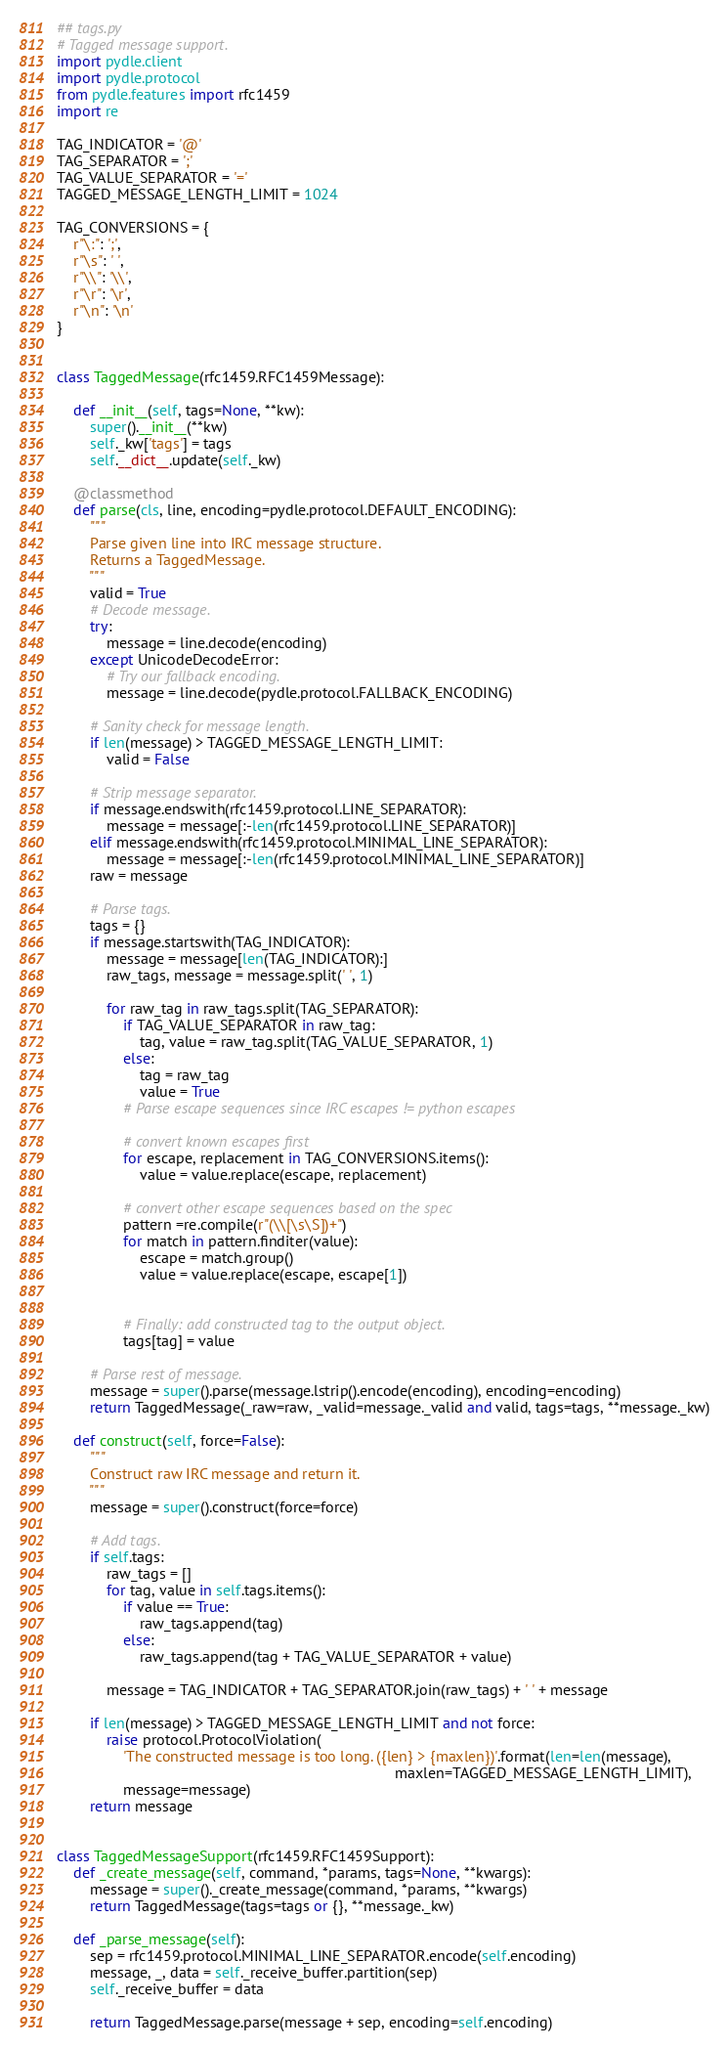<code> <loc_0><loc_0><loc_500><loc_500><_Python_>## tags.py
# Tagged message support.
import pydle.client
import pydle.protocol
from pydle.features import rfc1459
import re

TAG_INDICATOR = '@'
TAG_SEPARATOR = ';'
TAG_VALUE_SEPARATOR = '='
TAGGED_MESSAGE_LENGTH_LIMIT = 1024

TAG_CONVERSIONS = {
    r"\:": ';',
    r"\s": ' ',
    r"\\": '\\',
    r"\r": '\r',
    r"\n": '\n'
}


class TaggedMessage(rfc1459.RFC1459Message):

    def __init__(self, tags=None, **kw):
        super().__init__(**kw)
        self._kw['tags'] = tags
        self.__dict__.update(self._kw)

    @classmethod
    def parse(cls, line, encoding=pydle.protocol.DEFAULT_ENCODING):
        """
        Parse given line into IRC message structure.
        Returns a TaggedMessage.
        """
        valid = True
        # Decode message.
        try:
            message = line.decode(encoding)
        except UnicodeDecodeError:
            # Try our fallback encoding.
            message = line.decode(pydle.protocol.FALLBACK_ENCODING)

        # Sanity check for message length.
        if len(message) > TAGGED_MESSAGE_LENGTH_LIMIT:
            valid = False

        # Strip message separator.
        if message.endswith(rfc1459.protocol.LINE_SEPARATOR):
            message = message[:-len(rfc1459.protocol.LINE_SEPARATOR)]
        elif message.endswith(rfc1459.protocol.MINIMAL_LINE_SEPARATOR):
            message = message[:-len(rfc1459.protocol.MINIMAL_LINE_SEPARATOR)]
        raw = message

        # Parse tags.
        tags = {}
        if message.startswith(TAG_INDICATOR):
            message = message[len(TAG_INDICATOR):]
            raw_tags, message = message.split(' ', 1)

            for raw_tag in raw_tags.split(TAG_SEPARATOR):
                if TAG_VALUE_SEPARATOR in raw_tag:
                    tag, value = raw_tag.split(TAG_VALUE_SEPARATOR, 1)
                else:
                    tag = raw_tag
                    value = True
                # Parse escape sequences since IRC escapes != python escapes

                # convert known escapes first
                for escape, replacement in TAG_CONVERSIONS.items():
                    value = value.replace(escape, replacement)

                # convert other escape sequences based on the spec
                pattern =re.compile(r"(\\[\s\S])+")
                for match in pattern.finditer(value):
                    escape = match.group()
                    value = value.replace(escape, escape[1])


                # Finally: add constructed tag to the output object.
                tags[tag] = value

        # Parse rest of message.
        message = super().parse(message.lstrip().encode(encoding), encoding=encoding)
        return TaggedMessage(_raw=raw, _valid=message._valid and valid, tags=tags, **message._kw)

    def construct(self, force=False):
        """
        Construct raw IRC message and return it.
        """
        message = super().construct(force=force)

        # Add tags.
        if self.tags:
            raw_tags = []
            for tag, value in self.tags.items():
                if value == True:
                    raw_tags.append(tag)
                else:
                    raw_tags.append(tag + TAG_VALUE_SEPARATOR + value)

            message = TAG_INDICATOR + TAG_SEPARATOR.join(raw_tags) + ' ' + message

        if len(message) > TAGGED_MESSAGE_LENGTH_LIMIT and not force:
            raise protocol.ProtocolViolation(
                'The constructed message is too long. ({len} > {maxlen})'.format(len=len(message),
                                                                                 maxlen=TAGGED_MESSAGE_LENGTH_LIMIT),
                message=message)
        return message


class TaggedMessageSupport(rfc1459.RFC1459Support):
    def _create_message(self, command, *params, tags=None, **kwargs):
        message = super()._create_message(command, *params, **kwargs)
        return TaggedMessage(tags=tags or {}, **message._kw)

    def _parse_message(self):
        sep = rfc1459.protocol.MINIMAL_LINE_SEPARATOR.encode(self.encoding)
        message, _, data = self._receive_buffer.partition(sep)
        self._receive_buffer = data

        return TaggedMessage.parse(message + sep, encoding=self.encoding)
</code> 